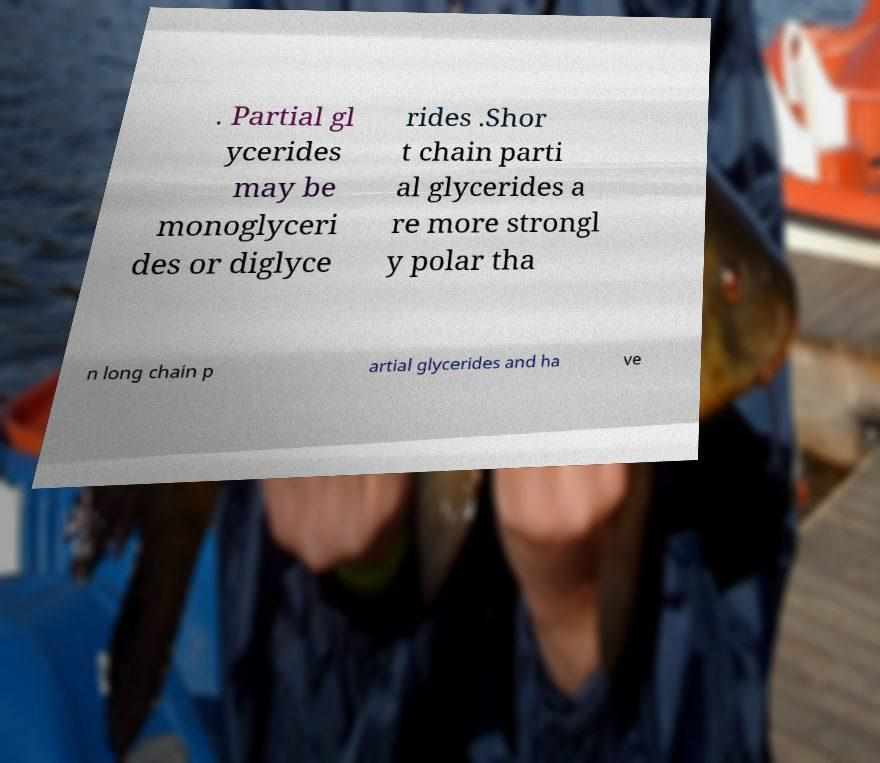Could you extract and type out the text from this image? . Partial gl ycerides may be monoglyceri des or diglyce rides .Shor t chain parti al glycerides a re more strongl y polar tha n long chain p artial glycerides and ha ve 